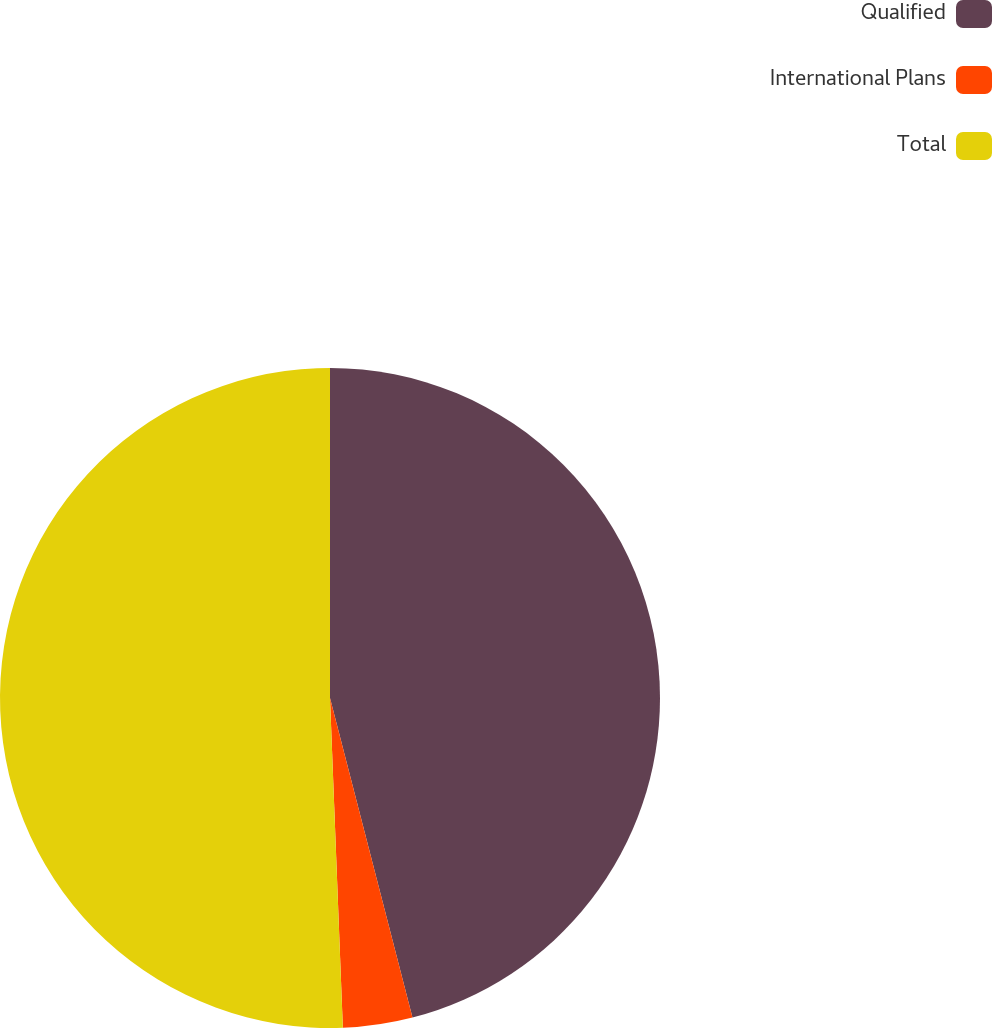<chart> <loc_0><loc_0><loc_500><loc_500><pie_chart><fcel>Qualified<fcel>International Plans<fcel>Total<nl><fcel>45.98%<fcel>3.4%<fcel>50.62%<nl></chart> 